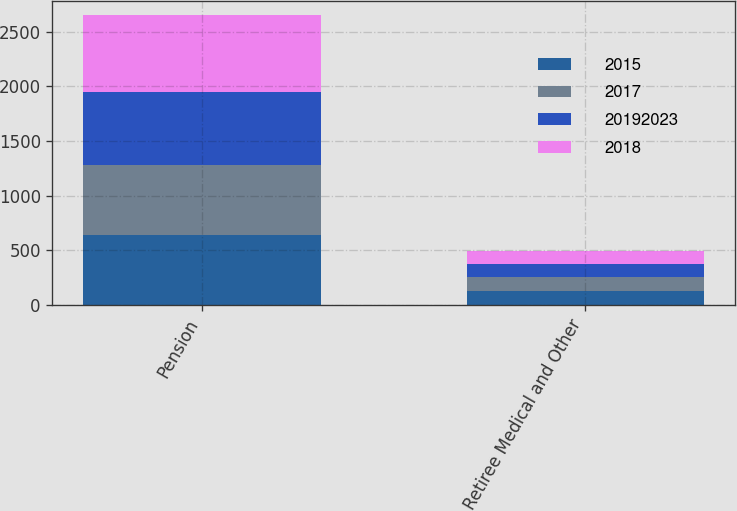<chart> <loc_0><loc_0><loc_500><loc_500><stacked_bar_chart><ecel><fcel>Pension<fcel>Retiree Medical and Other<nl><fcel>2015<fcel>642<fcel>130<nl><fcel>2017<fcel>642<fcel>125<nl><fcel>2.0192e+07<fcel>667<fcel>123<nl><fcel>2018<fcel>697<fcel>119<nl></chart> 